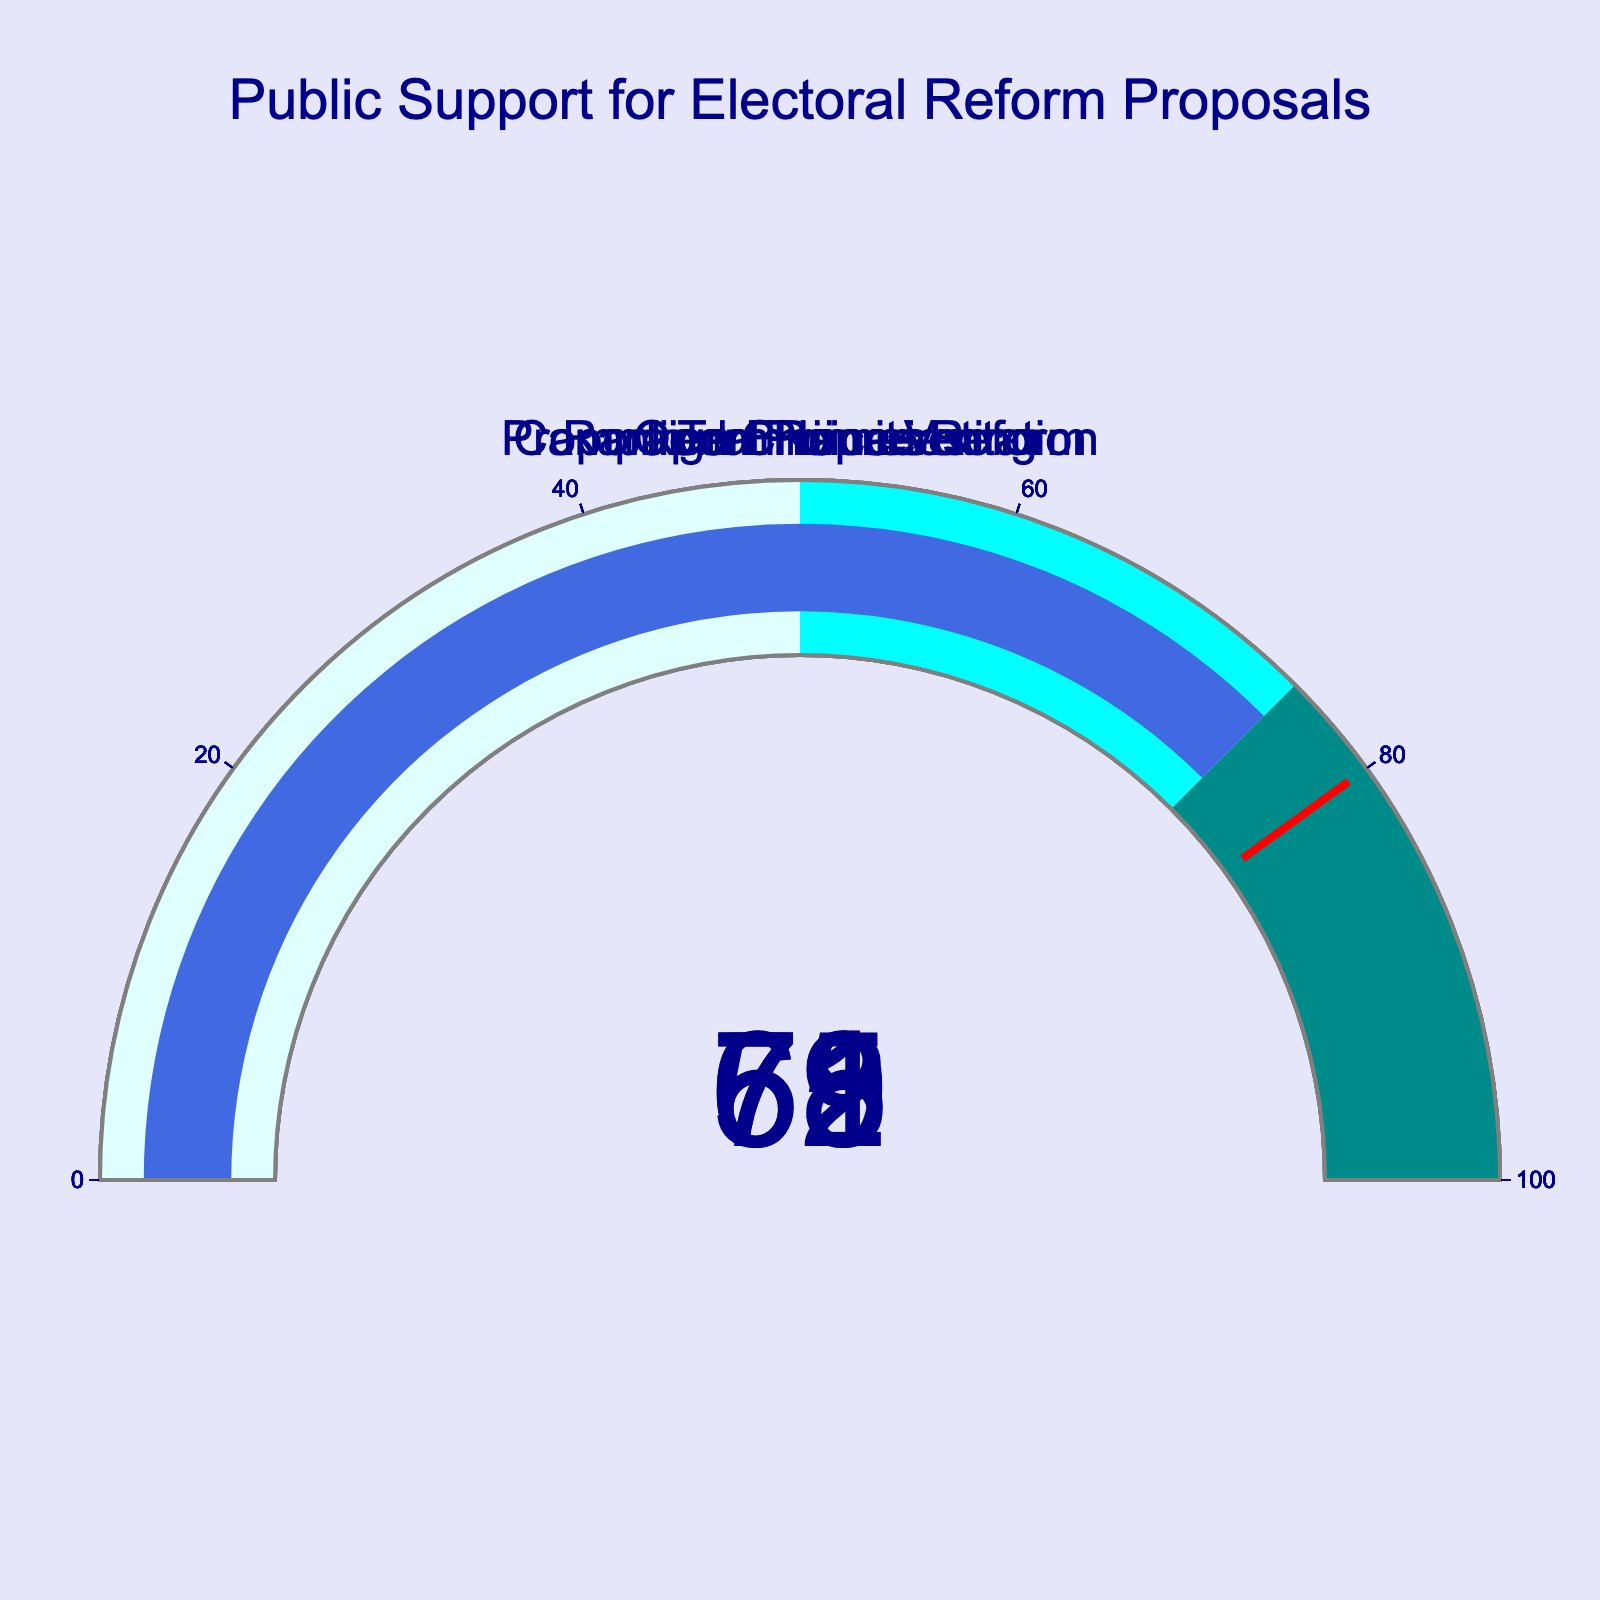How many different electoral reform proposals are displayed? The figure shows five gauges, each for a different electoral reform proposal, indicating the number of proposals displayed.
Answer: 5 What is the title of the figure? The title is displayed at the top center of the figure above all the gauges.
Answer: Public Support for Electoral Reform Proposals What percentage of support does Ranked Choice Voting have? The gauge corresponding to Ranked Choice Voting shows the number inside the gauge.
Answer: 62% Which electoral reform proposal has the highest public support? The proposal with the highest number on its gauge represents the highest public support.
Answer: Term Limits How much more support does Term Limits have compared to Campaign Finance Reform? Subtract the support percentage of Campaign Finance Reform from that of Term Limits using the numbers shown on each gauge. 75% - 69% = 6%
Answer: 6% Are there any proposals below 50% support? Check each gauge's number. If none are below 50, then all proposals have more than 50% support.
Answer: No What is the average support for all the electoral reform proposals? Sum all the support percentages and divide by the number of proposals: (62 + 58 + 71 + 69 + 75) / 5 = 67%
Answer: 67% Which two proposals have the closest levels of support? Compare the numbers on each gauge to find the smallest difference. The smallest difference is between Campaign Finance Reform (69%) and Open Primaries (71%).
Answer: Open Primaries and Campaign Finance Reform Which proposal has less support: Proportional Representation or Ranked Choice Voting? Compare the numbers on the gauges for Proportional Representation and Ranked Choice Voting. Proportional Representation is 58%, and Ranked Choice Voting is 62%.
Answer: Proportional Representation What are the colored ranges in the gauge’s background used for? The colored ranges represent different support intervals: light cyan for 0-50, cyan for 50-75, and dark cyan for 75-100. This visual helps identify the magnitude of support at a glance.
Answer: Support intervals 